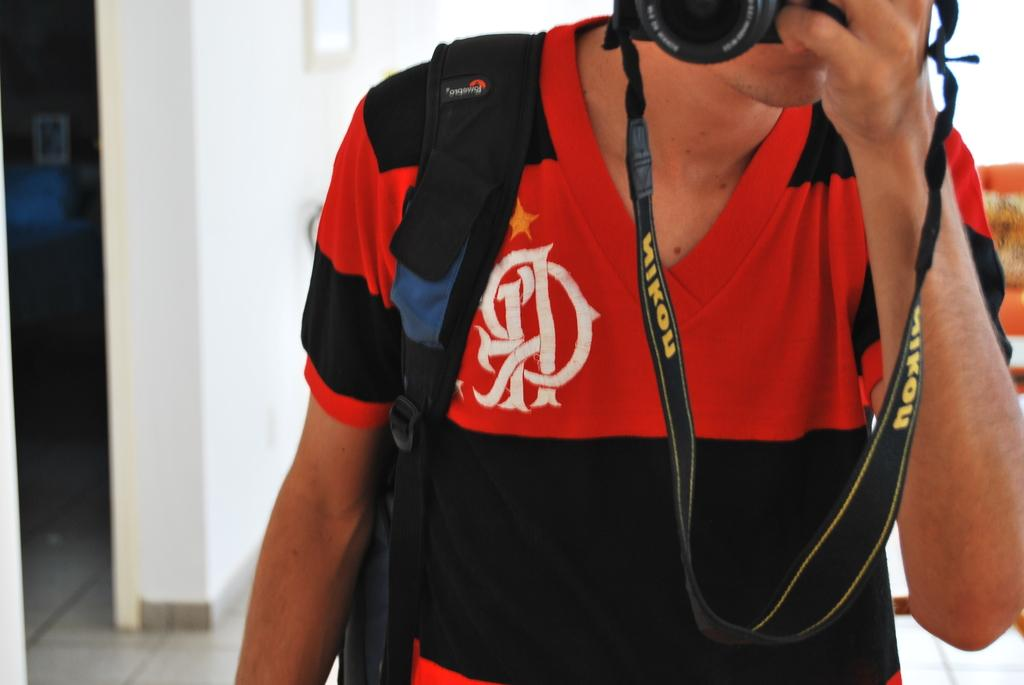Provide a one-sentence caption for the provided image. man in black and red shirt holding camera with nikon on strap. 